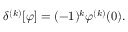Convert formula to latex. <formula><loc_0><loc_0><loc_500><loc_500>\delta ^ { ( k ) } [ \varphi ] = ( - 1 ) ^ { k } \varphi ^ { ( k ) } ( 0 ) .</formula> 